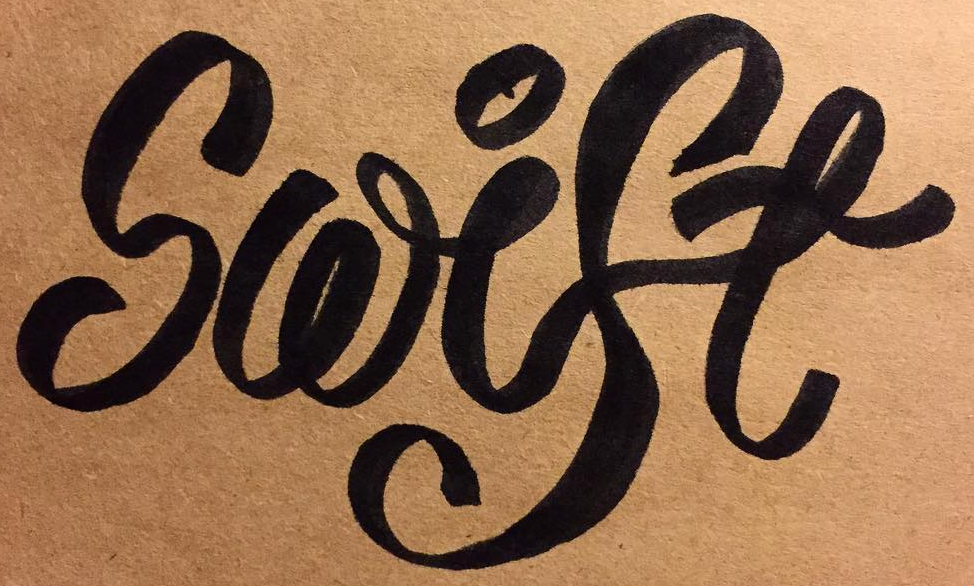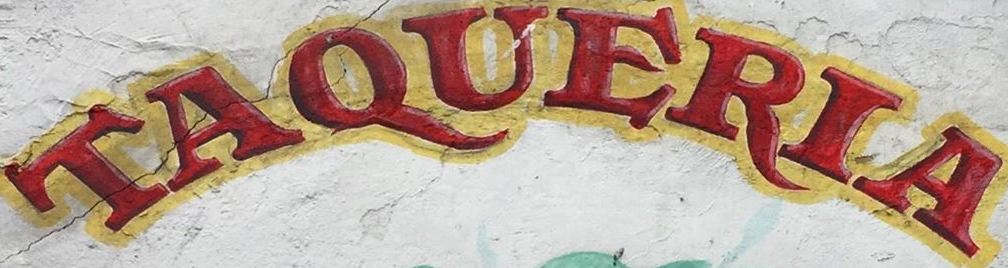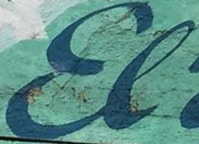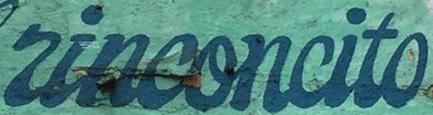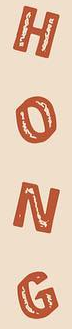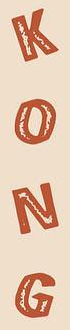What text appears in these images from left to right, separated by a semicolon? Swise; TAQUERIA; El; rinconcito; HONG; KONG 